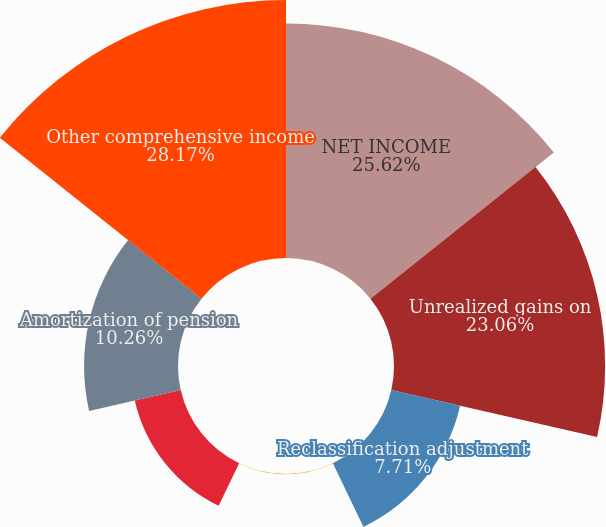<chart> <loc_0><loc_0><loc_500><loc_500><pie_chart><fcel>NET INCOME<fcel>Unrealized gains on<fcel>Reclassification adjustment<fcel>Unrealized (losses) gains on<fcel>Unrealized gains (losses) on<fcel>Amortization of pension<fcel>Other comprehensive income<nl><fcel>25.62%<fcel>23.06%<fcel>7.71%<fcel>0.03%<fcel>5.15%<fcel>10.26%<fcel>28.18%<nl></chart> 